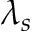Convert formula to latex. <formula><loc_0><loc_0><loc_500><loc_500>\lambda _ { s }</formula> 